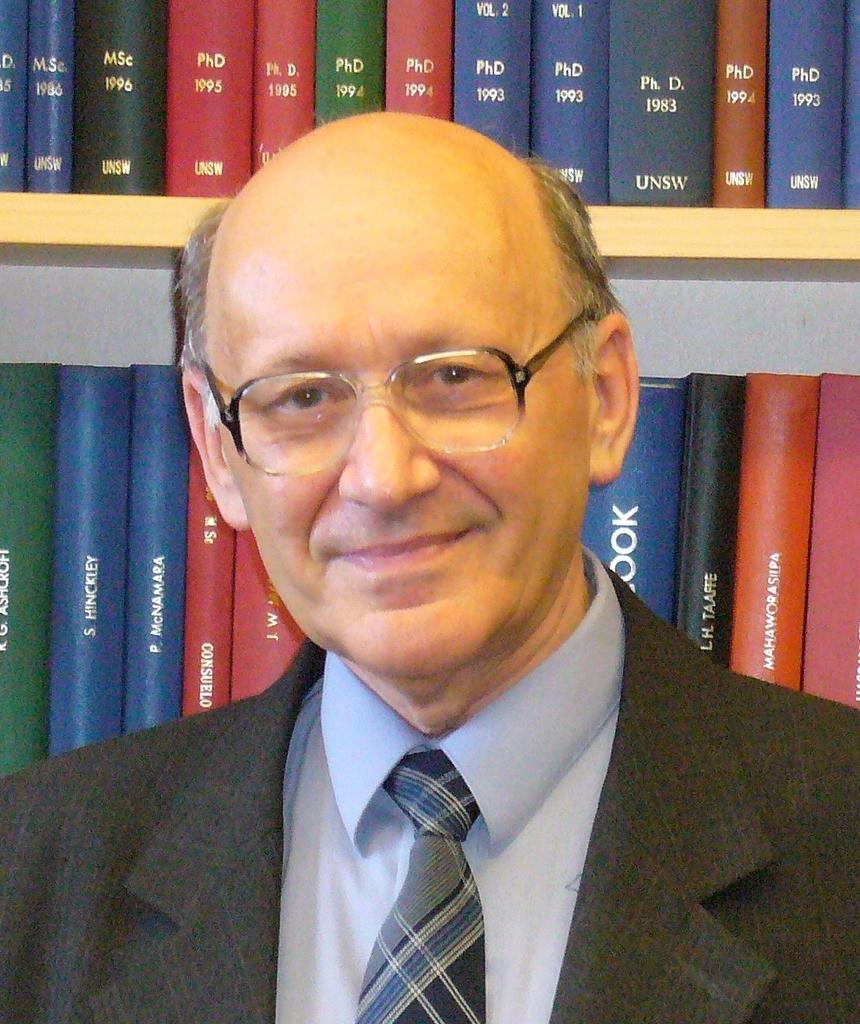What is the main subject of the image? There is a person in the image. What can be seen behind the person? There is a group of books behind the person. Can you describe the books in the image? There is text visible on the books. What type of haircut does the person have in the image? The provided facts do not mention the person's haircut, so we cannot determine it from the image. --- 